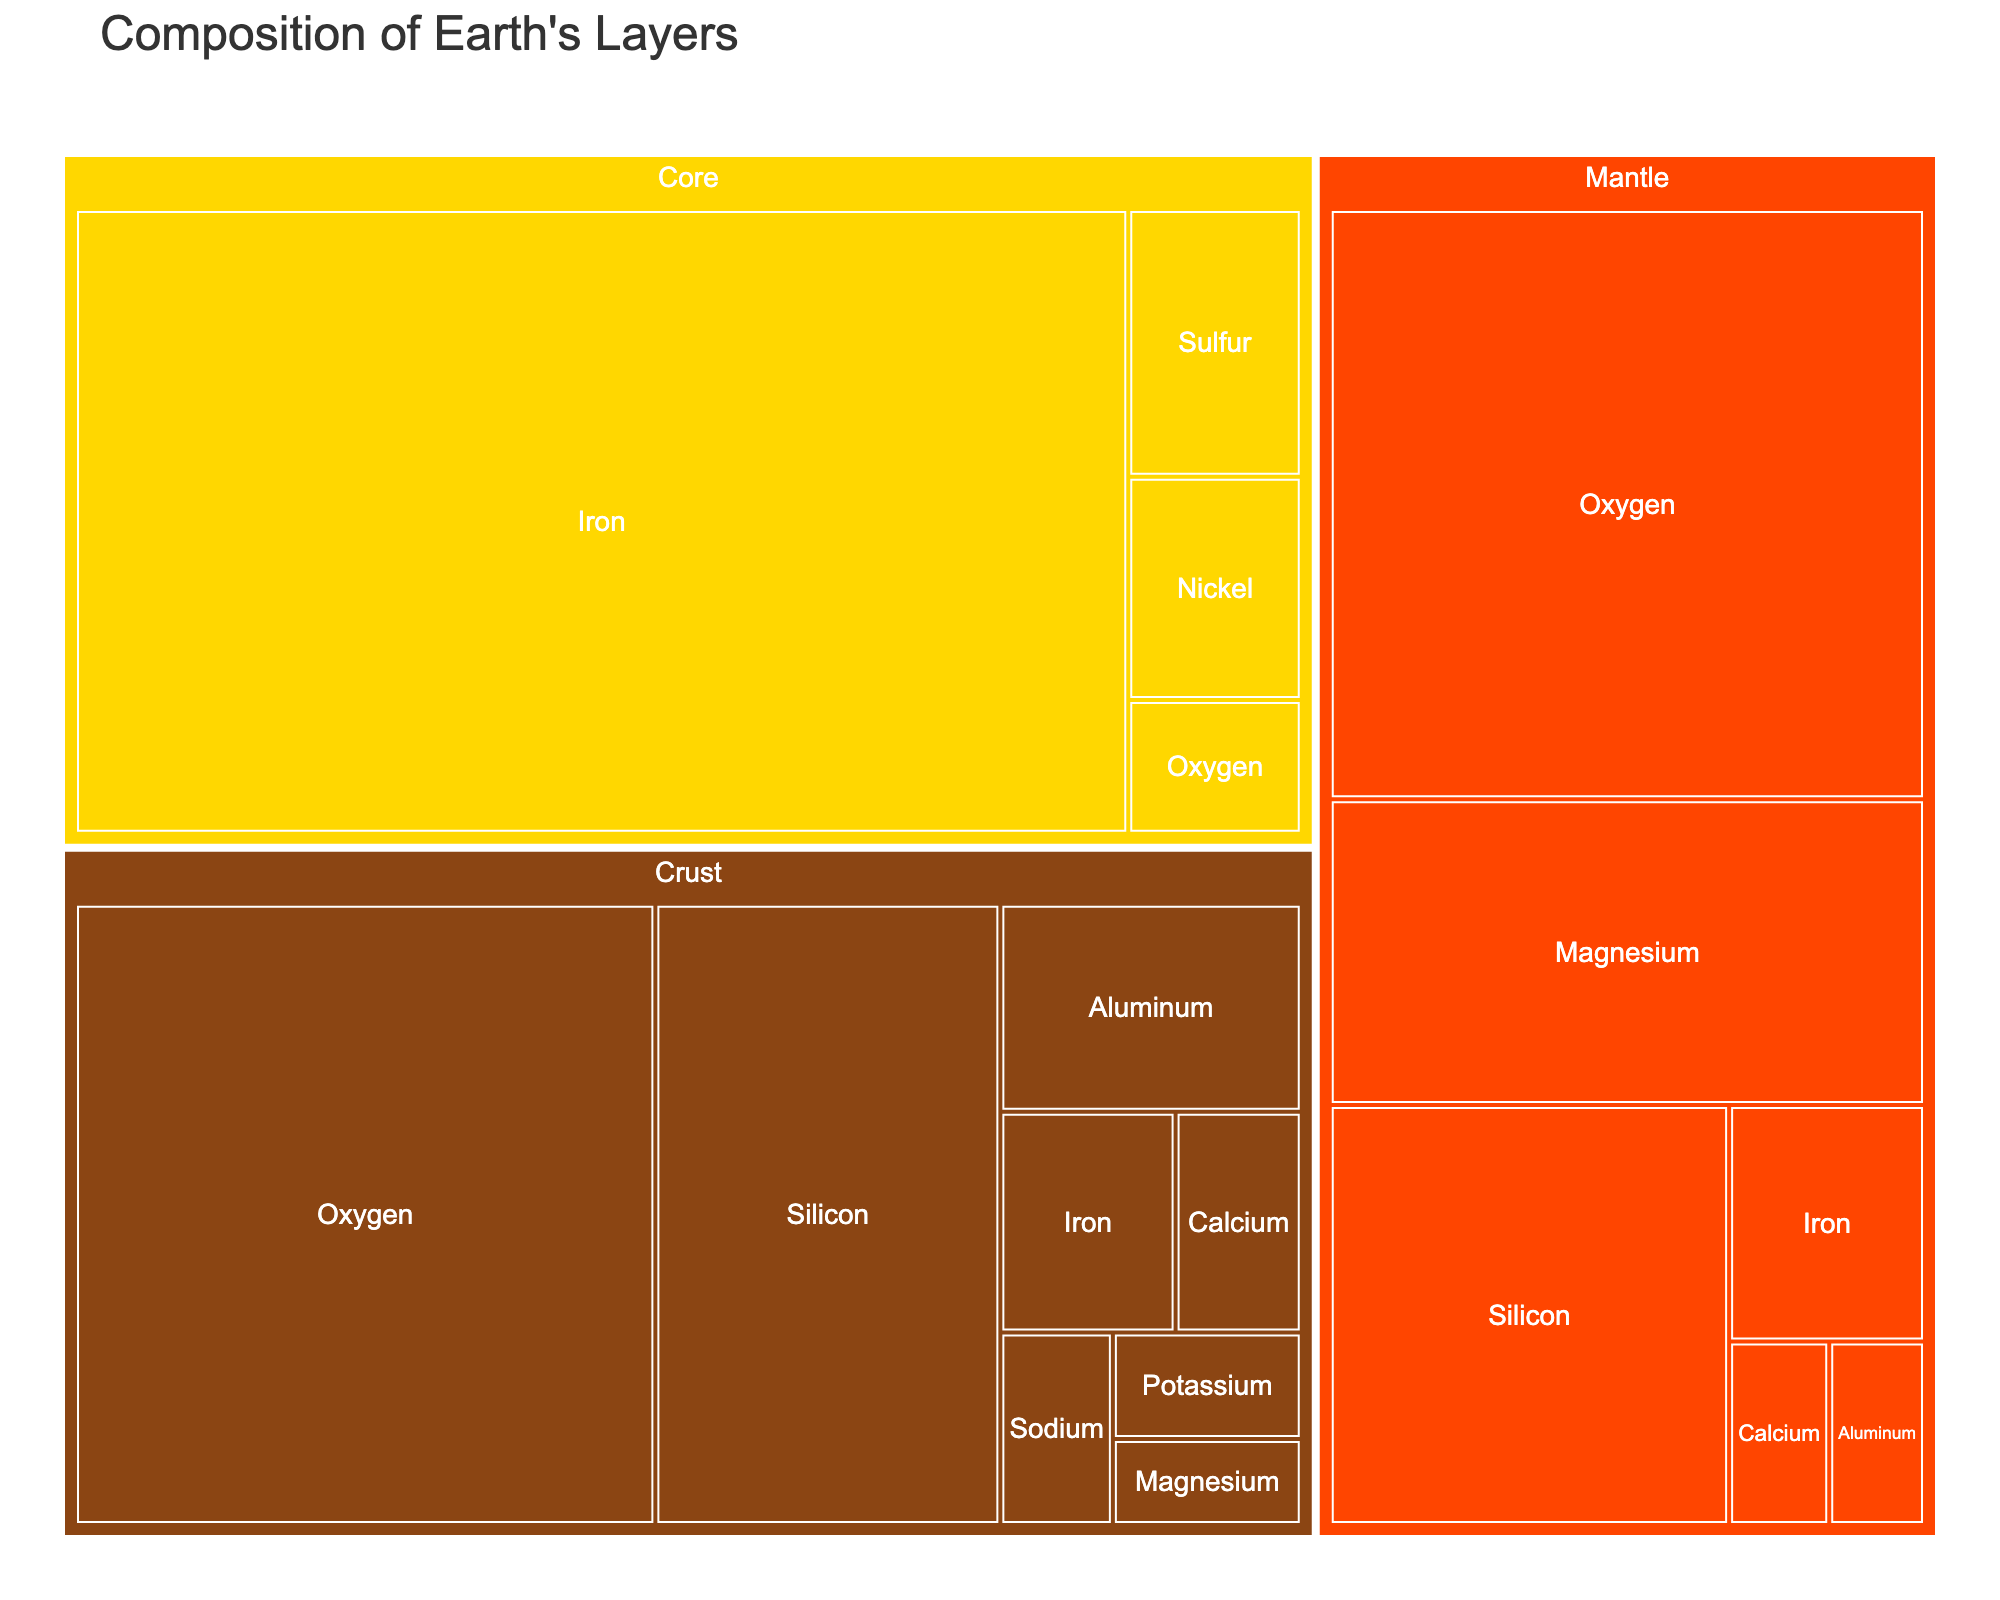What is the title of the treemap? The title is displayed at the top of the figure. It serves to give an overview of the subject matter represented within the treemap.
Answer: Composition of Earth's Layers Which element is the most abundant in the Earth's crust? Visual inspection of the treemap reveals that Oxygen occupies the largest segment within the 'Crust' category.
Answer: Oxygen Which layer contains the highest percentage of Iron? The treemap shows three layers: Crust, Mantle, and Core. By comparing the Iron sections in each layer, we see that the Core has the largest segment for Iron, 85%.
Answer: Core What is the percentage of Magnesium in the Mantle compared to the Crust? By examining the specific segments for Magnesium within both the Mantle and Crust categories, we find that Magnesium accounts for 22.8% in the Mantle and 2.1% in the Crust.
Answer: 22.8% in the Mantle and 2.1% in the Crust If you sum the percentage of Oxygen in the Crust and the Mantle, what value do you get? Adding the Oxygen percentages in both layers: 46.6% (Crust) + 44.0% (Mantle) = 90.6%
Answer: 90.6% In which layer is Silicon more prevalent? Comparing the Silicon segments, Silicon in the Crust is 27.7% and in the Mantle is 21.0%. Silicon is more prevalent in the Crust.
Answer: Crust What are the least abundant elements in the Core layer? The smallest segments within the Core are Nickel (5%) and Oxygen (3%).
Answer: Nickel and Oxygen How does the percentage of Iron in the Mantle compare to its percentage in the Crust? The treemap shows Iron at 5.8% in the Mantle and 5.0% in the Crust. Therefore, Iron is slightly more prevalent in the Mantle.
Answer: More in the Mantle (5.8% vs. 5.0%) Which layer has the most diverse composition in terms of elements? The Crust layer has the most varied composition, with eight distinct elements as compared to six in the Mantle and four in the Core.
Answer: Crust What is the combined percentage of Calcium in both the Crust and Mantle? Summing the percentages, Calcium accounts for 3.6% in the Crust and 2.3% in the Mantle. Therefore, the total is 3.6% + 2.3% = 5.9%.
Answer: 5.9% 